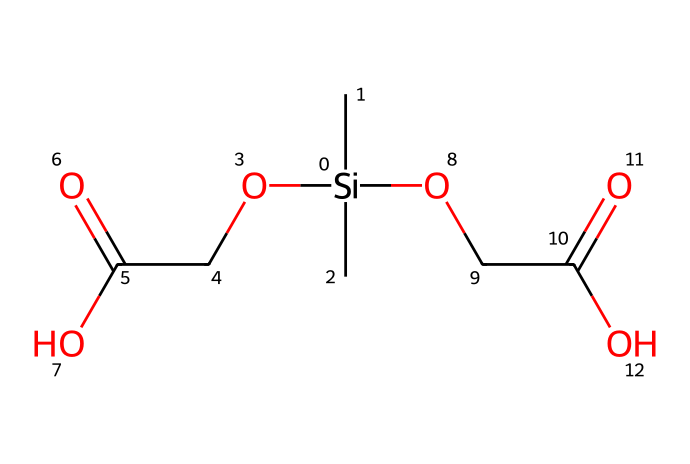What is the total number of silicon atoms in this chemical? The chemical structure contains one silicon atom, which can be identified from the SMILES notation [Si]. No additional silicon atoms are present.
Answer: one How many carbon atoms are present in the molecule? By counting the 'C' symbols in the SMILES representation, there are five carbon atoms in total: two from the two -C- groups bonded to silicon and three from the acetic acid moieties.
Answer: five What functional groups can be identified in this compound? The compound contains two ester groups (represented as OCC(=O)O), identified by the presence of carbonyl (C=O) and ether (C-O) linkages.
Answer: esters Does this chemical possess flame-retardant properties? The presence of silicon and the specified functional groups suggests that this compound may have flame-retardant properties, as organosilicon compounds are often utilized for their ability to withstand heat.
Answer: yes What type of reaction do organosilicon compounds generally undergo in a fire-resistant context? Organosilicon compounds typically undergo thermolysis, which leads to the formation of silicate char structures that enhance fire resistance upon exposure to high temperatures.
Answer: thermolysis Can the molecule be classified as a polymer? The SMILES structure represents a small organosilicon compound rather than a repeating unit of a polymer, as it does not exhibit a chain formation typical of polymers.
Answer: no What is the significance of the ester groups in fire-resistant applications? The ester groups in organizing the molecular structure help in maintaining the stability of the compound under thermal stress, thus contributing to its flame-retardant properties.
Answer: stability 